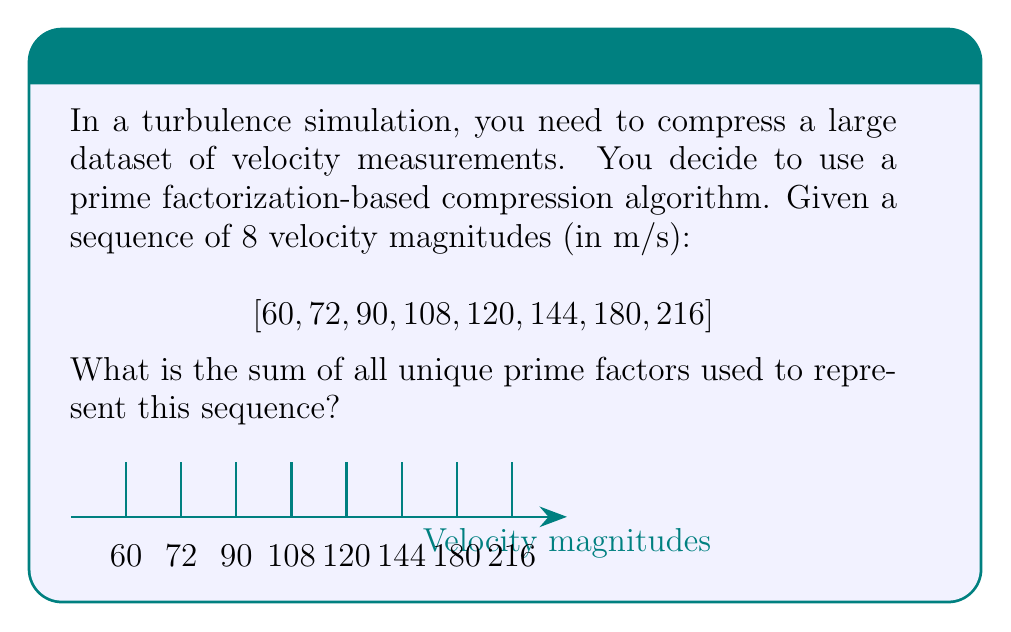Can you solve this math problem? Let's approach this step-by-step:

1) First, we need to find the prime factorization of each number in the sequence:

   60 = $2^2 \times 3 \times 5$
   72 = $2^3 \times 3^2$
   90 = $2 \times 3^2 \times 5$
   108 = $2^2 \times 3^3$
   120 = $2^3 \times 3 \times 5$
   144 = $2^4 \times 3^2$
   180 = $2^2 \times 3^2 \times 5$
   216 = $2^3 \times 3^3$

2) Now, let's identify all unique prime factors used:
   
   The unique prime factors are 2, 3, and 5.

3) Finally, we sum these unique prime factors:

   $2 + 3 + 5 = 10$

This sum represents the total number of unique prime bases needed to encode this velocity data sequence using a prime factorization-based compression algorithm. In a real-world scenario, this approach could significantly reduce the data storage requirements for large turbulence simulation datasets.
Answer: 10 